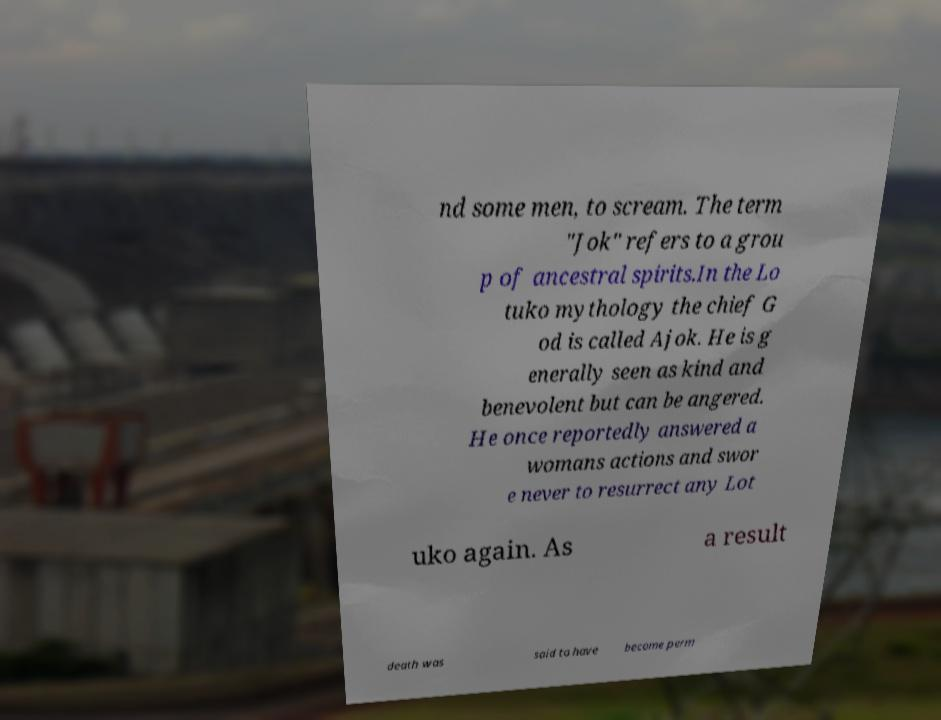Can you read and provide the text displayed in the image?This photo seems to have some interesting text. Can you extract and type it out for me? nd some men, to scream. The term "Jok" refers to a grou p of ancestral spirits.In the Lo tuko mythology the chief G od is called Ajok. He is g enerally seen as kind and benevolent but can be angered. He once reportedly answered a womans actions and swor e never to resurrect any Lot uko again. As a result death was said to have become perm 